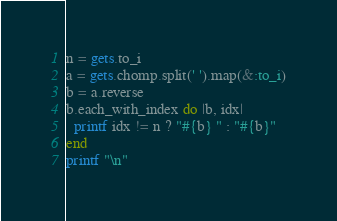Convert code to text. <code><loc_0><loc_0><loc_500><loc_500><_Ruby_>n = gets.to_i
a = gets.chomp.split(' ').map(&:to_i)
b = a.reverse
b.each_with_index do |b, idx|
  printf idx != n ? "#{b} " : "#{b}"
end
printf "\n"</code> 